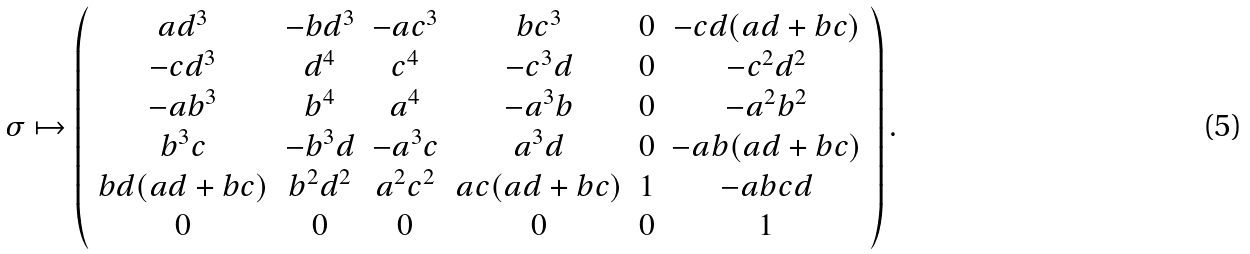<formula> <loc_0><loc_0><loc_500><loc_500>\sigma \mapsto \left ( \begin{array} { c c c c c c } a d ^ { 3 } & - b d ^ { 3 } & - a c ^ { 3 } & b c ^ { 3 } & 0 & - c d ( a d + b c ) \\ - c d ^ { 3 } & d ^ { 4 } & c ^ { 4 } & - c ^ { 3 } d & 0 & - c ^ { 2 } d ^ { 2 } \\ - a b ^ { 3 } & b ^ { 4 } & a ^ { 4 } & - a ^ { 3 } b & 0 & - a ^ { 2 } b ^ { 2 } \\ b ^ { 3 } c & - b ^ { 3 } d & - a ^ { 3 } c & a ^ { 3 } d & 0 & - a b ( a d + b c ) \\ b d ( a d + b c ) & b ^ { 2 } d ^ { 2 } & a ^ { 2 } c ^ { 2 } & a c ( a d + b c ) & 1 & - a b c d \\ 0 & 0 & 0 & 0 & 0 & 1 \end{array} \right ) .</formula> 